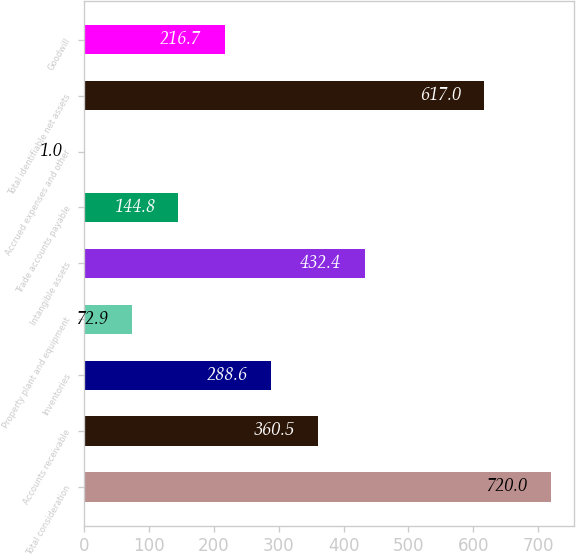<chart> <loc_0><loc_0><loc_500><loc_500><bar_chart><fcel>Total consideration<fcel>Accounts receivable<fcel>Inventories<fcel>Property plant and equipment<fcel>Intangible assets<fcel>Trade accounts payable<fcel>Accrued expenses and other<fcel>Total identifiable net assets<fcel>Goodwill<nl><fcel>720<fcel>360.5<fcel>288.6<fcel>72.9<fcel>432.4<fcel>144.8<fcel>1<fcel>617<fcel>216.7<nl></chart> 